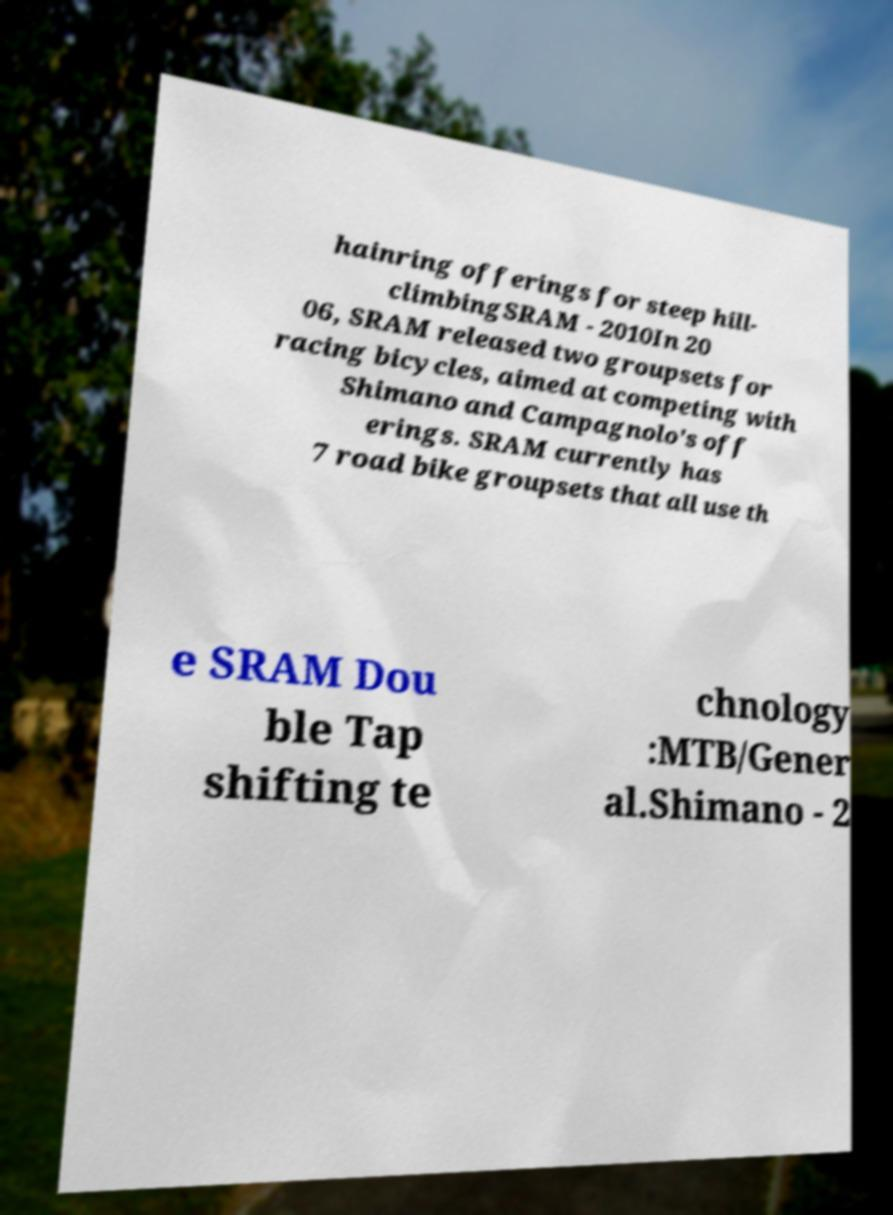For documentation purposes, I need the text within this image transcribed. Could you provide that? hainring offerings for steep hill- climbingSRAM - 2010In 20 06, SRAM released two groupsets for racing bicycles, aimed at competing with Shimano and Campagnolo's off erings. SRAM currently has 7 road bike groupsets that all use th e SRAM Dou ble Tap shifting te chnology :MTB/Gener al.Shimano - 2 